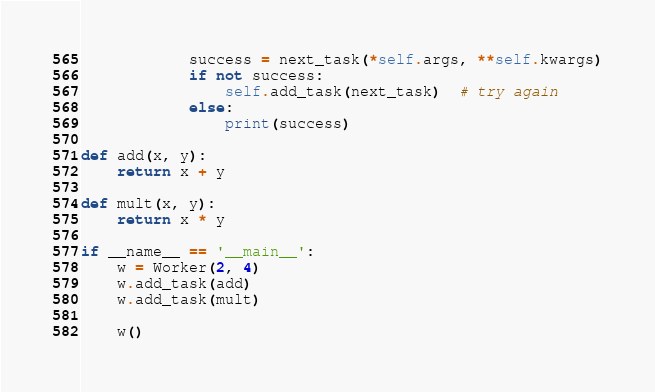<code> <loc_0><loc_0><loc_500><loc_500><_Python_>            success = next_task(*self.args, **self.kwargs)
            if not success:
                self.add_task(next_task)  # try again
            else:
                print(success)

def add(x, y):
    return x + y

def mult(x, y):
    return x * y

if __name__ == '__main__':
    w = Worker(2, 4)
    w.add_task(add)
    w.add_task(mult)

    w()
</code> 